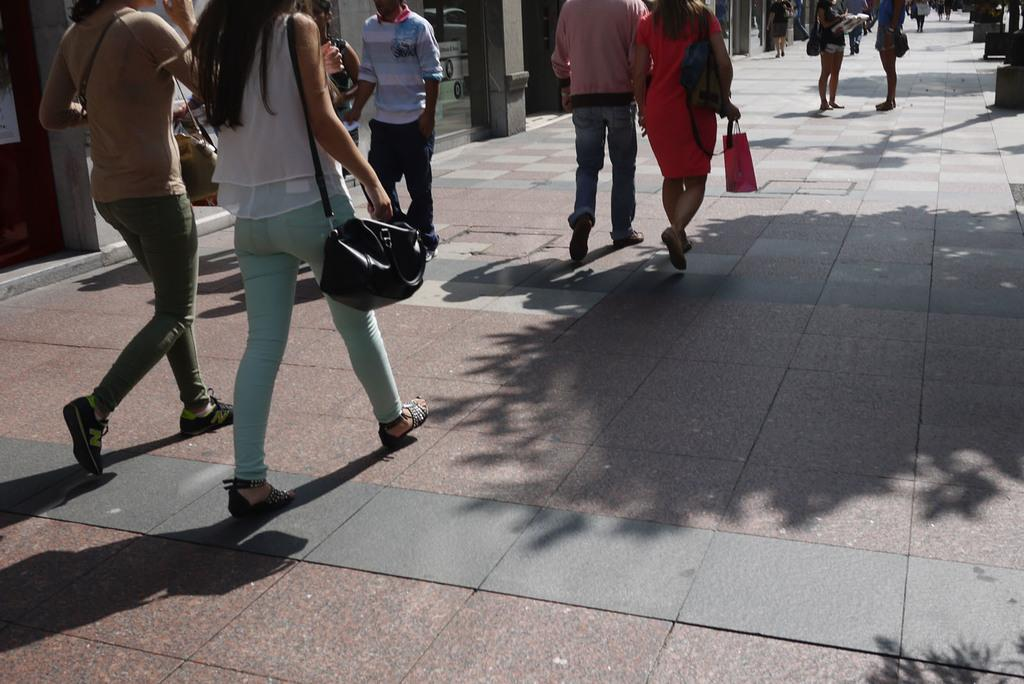What are the people in the image doing? The people in the image are walking on a path. Can you describe the gender of the people walking? There are both men and women among the people walking. What can be seen in the background of the image? There are buildings in the background of the image. What type of cough can be heard from the people walking in the image? There is no indication of any cough or sound in the image, as it only shows people walking on a path. 